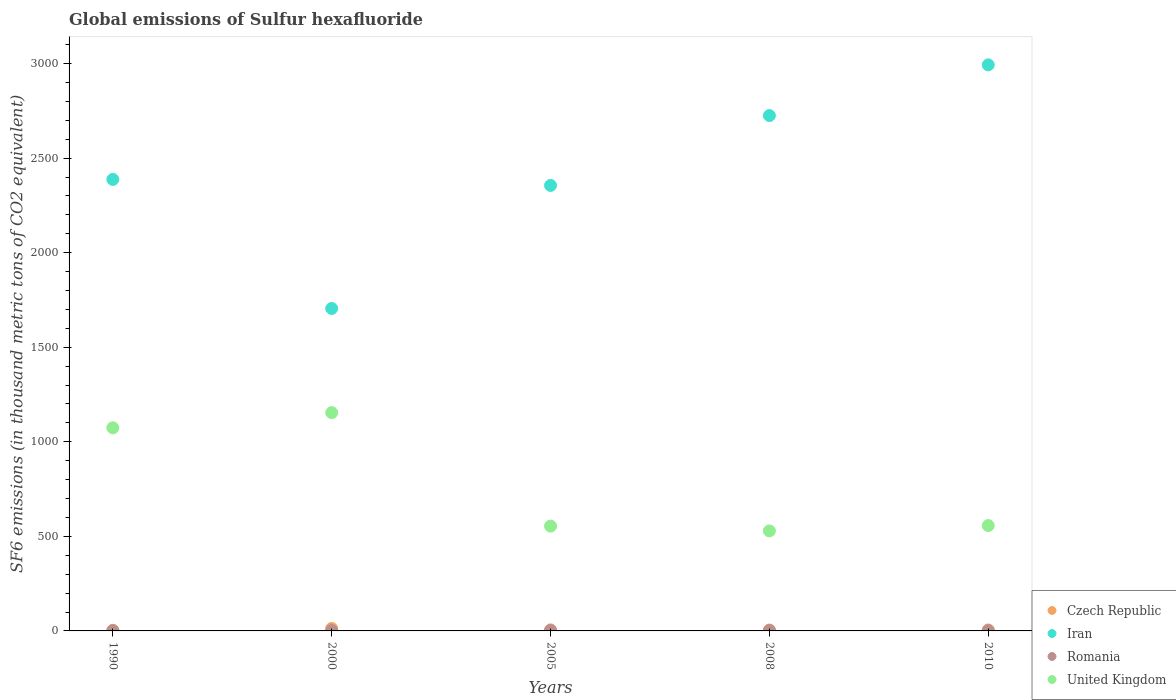What is the global emissions of Sulfur hexafluoride in United Kingdom in 2000?
Provide a short and direct response. 1154.1. Across all years, what is the maximum global emissions of Sulfur hexafluoride in United Kingdom?
Provide a short and direct response. 1154.1. Across all years, what is the minimum global emissions of Sulfur hexafluoride in Iran?
Ensure brevity in your answer.  1704.9. In which year was the global emissions of Sulfur hexafluoride in Romania maximum?
Your answer should be very brief. 2008. What is the total global emissions of Sulfur hexafluoride in Romania in the graph?
Make the answer very short. 10.1. What is the difference between the global emissions of Sulfur hexafluoride in United Kingdom in 1990 and that in 2008?
Your answer should be very brief. 545. What is the difference between the global emissions of Sulfur hexafluoride in Romania in 1990 and the global emissions of Sulfur hexafluoride in Czech Republic in 2008?
Provide a succinct answer. -3.1. What is the average global emissions of Sulfur hexafluoride in United Kingdom per year?
Provide a succinct answer. 773.62. In the year 2008, what is the difference between the global emissions of Sulfur hexafluoride in United Kingdom and global emissions of Sulfur hexafluoride in Iran?
Your answer should be very brief. -2196. What is the ratio of the global emissions of Sulfur hexafluoride in Iran in 2000 to that in 2008?
Offer a terse response. 0.63. Is the global emissions of Sulfur hexafluoride in Romania in 1990 less than that in 2010?
Your answer should be very brief. Yes. What is the difference between the highest and the second highest global emissions of Sulfur hexafluoride in Romania?
Your answer should be very brief. 0.1. What is the difference between the highest and the lowest global emissions of Sulfur hexafluoride in Romania?
Ensure brevity in your answer.  0.7. In how many years, is the global emissions of Sulfur hexafluoride in Romania greater than the average global emissions of Sulfur hexafluoride in Romania taken over all years?
Offer a terse response. 2. Is the sum of the global emissions of Sulfur hexafluoride in Czech Republic in 1990 and 2010 greater than the maximum global emissions of Sulfur hexafluoride in Iran across all years?
Make the answer very short. No. Is it the case that in every year, the sum of the global emissions of Sulfur hexafluoride in United Kingdom and global emissions of Sulfur hexafluoride in Czech Republic  is greater than the sum of global emissions of Sulfur hexafluoride in Romania and global emissions of Sulfur hexafluoride in Iran?
Make the answer very short. No. Does the global emissions of Sulfur hexafluoride in Czech Republic monotonically increase over the years?
Offer a very short reply. No. Where does the legend appear in the graph?
Provide a short and direct response. Bottom right. How are the legend labels stacked?
Your answer should be very brief. Vertical. What is the title of the graph?
Make the answer very short. Global emissions of Sulfur hexafluoride. What is the label or title of the X-axis?
Offer a very short reply. Years. What is the label or title of the Y-axis?
Keep it short and to the point. SF6 emissions (in thousand metric tons of CO2 equivalent). What is the SF6 emissions (in thousand metric tons of CO2 equivalent) in Iran in 1990?
Provide a succinct answer. 2387.3. What is the SF6 emissions (in thousand metric tons of CO2 equivalent) of Romania in 1990?
Provide a succinct answer. 1.6. What is the SF6 emissions (in thousand metric tons of CO2 equivalent) of United Kingdom in 1990?
Your answer should be very brief. 1073.9. What is the SF6 emissions (in thousand metric tons of CO2 equivalent) in Iran in 2000?
Give a very brief answer. 1704.9. What is the SF6 emissions (in thousand metric tons of CO2 equivalent) in United Kingdom in 2000?
Keep it short and to the point. 1154.1. What is the SF6 emissions (in thousand metric tons of CO2 equivalent) in Iran in 2005?
Your answer should be compact. 2355.5. What is the SF6 emissions (in thousand metric tons of CO2 equivalent) in United Kingdom in 2005?
Keep it short and to the point. 554.2. What is the SF6 emissions (in thousand metric tons of CO2 equivalent) of Iran in 2008?
Provide a succinct answer. 2724.9. What is the SF6 emissions (in thousand metric tons of CO2 equivalent) of United Kingdom in 2008?
Ensure brevity in your answer.  528.9. What is the SF6 emissions (in thousand metric tons of CO2 equivalent) of Iran in 2010?
Your response must be concise. 2993. What is the SF6 emissions (in thousand metric tons of CO2 equivalent) of United Kingdom in 2010?
Make the answer very short. 557. Across all years, what is the maximum SF6 emissions (in thousand metric tons of CO2 equivalent) of Czech Republic?
Make the answer very short. 13. Across all years, what is the maximum SF6 emissions (in thousand metric tons of CO2 equivalent) in Iran?
Give a very brief answer. 2993. Across all years, what is the maximum SF6 emissions (in thousand metric tons of CO2 equivalent) of United Kingdom?
Your answer should be compact. 1154.1. Across all years, what is the minimum SF6 emissions (in thousand metric tons of CO2 equivalent) of Iran?
Your answer should be very brief. 1704.9. Across all years, what is the minimum SF6 emissions (in thousand metric tons of CO2 equivalent) of United Kingdom?
Keep it short and to the point. 528.9. What is the total SF6 emissions (in thousand metric tons of CO2 equivalent) of Czech Republic in the graph?
Offer a very short reply. 31.6. What is the total SF6 emissions (in thousand metric tons of CO2 equivalent) of Iran in the graph?
Provide a succinct answer. 1.22e+04. What is the total SF6 emissions (in thousand metric tons of CO2 equivalent) of Romania in the graph?
Provide a succinct answer. 10.1. What is the total SF6 emissions (in thousand metric tons of CO2 equivalent) of United Kingdom in the graph?
Offer a very short reply. 3868.1. What is the difference between the SF6 emissions (in thousand metric tons of CO2 equivalent) of Iran in 1990 and that in 2000?
Give a very brief answer. 682.4. What is the difference between the SF6 emissions (in thousand metric tons of CO2 equivalent) of Romania in 1990 and that in 2000?
Offer a terse response. -0.4. What is the difference between the SF6 emissions (in thousand metric tons of CO2 equivalent) in United Kingdom in 1990 and that in 2000?
Keep it short and to the point. -80.2. What is the difference between the SF6 emissions (in thousand metric tons of CO2 equivalent) in Iran in 1990 and that in 2005?
Give a very brief answer. 31.8. What is the difference between the SF6 emissions (in thousand metric tons of CO2 equivalent) in Romania in 1990 and that in 2005?
Offer a terse response. -0.6. What is the difference between the SF6 emissions (in thousand metric tons of CO2 equivalent) in United Kingdom in 1990 and that in 2005?
Make the answer very short. 519.7. What is the difference between the SF6 emissions (in thousand metric tons of CO2 equivalent) in Iran in 1990 and that in 2008?
Keep it short and to the point. -337.6. What is the difference between the SF6 emissions (in thousand metric tons of CO2 equivalent) of United Kingdom in 1990 and that in 2008?
Your response must be concise. 545. What is the difference between the SF6 emissions (in thousand metric tons of CO2 equivalent) in Iran in 1990 and that in 2010?
Offer a very short reply. -605.7. What is the difference between the SF6 emissions (in thousand metric tons of CO2 equivalent) in Romania in 1990 and that in 2010?
Keep it short and to the point. -0.4. What is the difference between the SF6 emissions (in thousand metric tons of CO2 equivalent) in United Kingdom in 1990 and that in 2010?
Provide a succinct answer. 516.9. What is the difference between the SF6 emissions (in thousand metric tons of CO2 equivalent) in Czech Republic in 2000 and that in 2005?
Your response must be concise. 7.4. What is the difference between the SF6 emissions (in thousand metric tons of CO2 equivalent) of Iran in 2000 and that in 2005?
Your answer should be very brief. -650.6. What is the difference between the SF6 emissions (in thousand metric tons of CO2 equivalent) in United Kingdom in 2000 and that in 2005?
Ensure brevity in your answer.  599.9. What is the difference between the SF6 emissions (in thousand metric tons of CO2 equivalent) in Iran in 2000 and that in 2008?
Make the answer very short. -1020. What is the difference between the SF6 emissions (in thousand metric tons of CO2 equivalent) in United Kingdom in 2000 and that in 2008?
Provide a short and direct response. 625.2. What is the difference between the SF6 emissions (in thousand metric tons of CO2 equivalent) of Czech Republic in 2000 and that in 2010?
Your answer should be very brief. 8. What is the difference between the SF6 emissions (in thousand metric tons of CO2 equivalent) of Iran in 2000 and that in 2010?
Provide a succinct answer. -1288.1. What is the difference between the SF6 emissions (in thousand metric tons of CO2 equivalent) of Romania in 2000 and that in 2010?
Your response must be concise. 0. What is the difference between the SF6 emissions (in thousand metric tons of CO2 equivalent) in United Kingdom in 2000 and that in 2010?
Your answer should be very brief. 597.1. What is the difference between the SF6 emissions (in thousand metric tons of CO2 equivalent) in Iran in 2005 and that in 2008?
Ensure brevity in your answer.  -369.4. What is the difference between the SF6 emissions (in thousand metric tons of CO2 equivalent) of Romania in 2005 and that in 2008?
Your answer should be compact. -0.1. What is the difference between the SF6 emissions (in thousand metric tons of CO2 equivalent) in United Kingdom in 2005 and that in 2008?
Give a very brief answer. 25.3. What is the difference between the SF6 emissions (in thousand metric tons of CO2 equivalent) of Iran in 2005 and that in 2010?
Provide a short and direct response. -637.5. What is the difference between the SF6 emissions (in thousand metric tons of CO2 equivalent) in United Kingdom in 2005 and that in 2010?
Your response must be concise. -2.8. What is the difference between the SF6 emissions (in thousand metric tons of CO2 equivalent) of Czech Republic in 2008 and that in 2010?
Your answer should be compact. -0.3. What is the difference between the SF6 emissions (in thousand metric tons of CO2 equivalent) in Iran in 2008 and that in 2010?
Your answer should be compact. -268.1. What is the difference between the SF6 emissions (in thousand metric tons of CO2 equivalent) in United Kingdom in 2008 and that in 2010?
Give a very brief answer. -28.1. What is the difference between the SF6 emissions (in thousand metric tons of CO2 equivalent) of Czech Republic in 1990 and the SF6 emissions (in thousand metric tons of CO2 equivalent) of Iran in 2000?
Ensure brevity in your answer.  -1701.6. What is the difference between the SF6 emissions (in thousand metric tons of CO2 equivalent) in Czech Republic in 1990 and the SF6 emissions (in thousand metric tons of CO2 equivalent) in Romania in 2000?
Ensure brevity in your answer.  1.3. What is the difference between the SF6 emissions (in thousand metric tons of CO2 equivalent) in Czech Republic in 1990 and the SF6 emissions (in thousand metric tons of CO2 equivalent) in United Kingdom in 2000?
Make the answer very short. -1150.8. What is the difference between the SF6 emissions (in thousand metric tons of CO2 equivalent) of Iran in 1990 and the SF6 emissions (in thousand metric tons of CO2 equivalent) of Romania in 2000?
Offer a very short reply. 2385.3. What is the difference between the SF6 emissions (in thousand metric tons of CO2 equivalent) in Iran in 1990 and the SF6 emissions (in thousand metric tons of CO2 equivalent) in United Kingdom in 2000?
Your answer should be compact. 1233.2. What is the difference between the SF6 emissions (in thousand metric tons of CO2 equivalent) in Romania in 1990 and the SF6 emissions (in thousand metric tons of CO2 equivalent) in United Kingdom in 2000?
Offer a very short reply. -1152.5. What is the difference between the SF6 emissions (in thousand metric tons of CO2 equivalent) in Czech Republic in 1990 and the SF6 emissions (in thousand metric tons of CO2 equivalent) in Iran in 2005?
Keep it short and to the point. -2352.2. What is the difference between the SF6 emissions (in thousand metric tons of CO2 equivalent) of Czech Republic in 1990 and the SF6 emissions (in thousand metric tons of CO2 equivalent) of United Kingdom in 2005?
Provide a short and direct response. -550.9. What is the difference between the SF6 emissions (in thousand metric tons of CO2 equivalent) in Iran in 1990 and the SF6 emissions (in thousand metric tons of CO2 equivalent) in Romania in 2005?
Your answer should be compact. 2385.1. What is the difference between the SF6 emissions (in thousand metric tons of CO2 equivalent) of Iran in 1990 and the SF6 emissions (in thousand metric tons of CO2 equivalent) of United Kingdom in 2005?
Provide a short and direct response. 1833.1. What is the difference between the SF6 emissions (in thousand metric tons of CO2 equivalent) in Romania in 1990 and the SF6 emissions (in thousand metric tons of CO2 equivalent) in United Kingdom in 2005?
Your response must be concise. -552.6. What is the difference between the SF6 emissions (in thousand metric tons of CO2 equivalent) in Czech Republic in 1990 and the SF6 emissions (in thousand metric tons of CO2 equivalent) in Iran in 2008?
Ensure brevity in your answer.  -2721.6. What is the difference between the SF6 emissions (in thousand metric tons of CO2 equivalent) in Czech Republic in 1990 and the SF6 emissions (in thousand metric tons of CO2 equivalent) in United Kingdom in 2008?
Offer a very short reply. -525.6. What is the difference between the SF6 emissions (in thousand metric tons of CO2 equivalent) in Iran in 1990 and the SF6 emissions (in thousand metric tons of CO2 equivalent) in Romania in 2008?
Make the answer very short. 2385. What is the difference between the SF6 emissions (in thousand metric tons of CO2 equivalent) in Iran in 1990 and the SF6 emissions (in thousand metric tons of CO2 equivalent) in United Kingdom in 2008?
Your response must be concise. 1858.4. What is the difference between the SF6 emissions (in thousand metric tons of CO2 equivalent) of Romania in 1990 and the SF6 emissions (in thousand metric tons of CO2 equivalent) of United Kingdom in 2008?
Ensure brevity in your answer.  -527.3. What is the difference between the SF6 emissions (in thousand metric tons of CO2 equivalent) of Czech Republic in 1990 and the SF6 emissions (in thousand metric tons of CO2 equivalent) of Iran in 2010?
Provide a short and direct response. -2989.7. What is the difference between the SF6 emissions (in thousand metric tons of CO2 equivalent) of Czech Republic in 1990 and the SF6 emissions (in thousand metric tons of CO2 equivalent) of United Kingdom in 2010?
Your response must be concise. -553.7. What is the difference between the SF6 emissions (in thousand metric tons of CO2 equivalent) in Iran in 1990 and the SF6 emissions (in thousand metric tons of CO2 equivalent) in Romania in 2010?
Provide a short and direct response. 2385.3. What is the difference between the SF6 emissions (in thousand metric tons of CO2 equivalent) in Iran in 1990 and the SF6 emissions (in thousand metric tons of CO2 equivalent) in United Kingdom in 2010?
Your answer should be very brief. 1830.3. What is the difference between the SF6 emissions (in thousand metric tons of CO2 equivalent) of Romania in 1990 and the SF6 emissions (in thousand metric tons of CO2 equivalent) of United Kingdom in 2010?
Keep it short and to the point. -555.4. What is the difference between the SF6 emissions (in thousand metric tons of CO2 equivalent) in Czech Republic in 2000 and the SF6 emissions (in thousand metric tons of CO2 equivalent) in Iran in 2005?
Give a very brief answer. -2342.5. What is the difference between the SF6 emissions (in thousand metric tons of CO2 equivalent) in Czech Republic in 2000 and the SF6 emissions (in thousand metric tons of CO2 equivalent) in United Kingdom in 2005?
Provide a succinct answer. -541.2. What is the difference between the SF6 emissions (in thousand metric tons of CO2 equivalent) of Iran in 2000 and the SF6 emissions (in thousand metric tons of CO2 equivalent) of Romania in 2005?
Ensure brevity in your answer.  1702.7. What is the difference between the SF6 emissions (in thousand metric tons of CO2 equivalent) of Iran in 2000 and the SF6 emissions (in thousand metric tons of CO2 equivalent) of United Kingdom in 2005?
Provide a succinct answer. 1150.7. What is the difference between the SF6 emissions (in thousand metric tons of CO2 equivalent) in Romania in 2000 and the SF6 emissions (in thousand metric tons of CO2 equivalent) in United Kingdom in 2005?
Make the answer very short. -552.2. What is the difference between the SF6 emissions (in thousand metric tons of CO2 equivalent) in Czech Republic in 2000 and the SF6 emissions (in thousand metric tons of CO2 equivalent) in Iran in 2008?
Provide a short and direct response. -2711.9. What is the difference between the SF6 emissions (in thousand metric tons of CO2 equivalent) of Czech Republic in 2000 and the SF6 emissions (in thousand metric tons of CO2 equivalent) of United Kingdom in 2008?
Ensure brevity in your answer.  -515.9. What is the difference between the SF6 emissions (in thousand metric tons of CO2 equivalent) in Iran in 2000 and the SF6 emissions (in thousand metric tons of CO2 equivalent) in Romania in 2008?
Ensure brevity in your answer.  1702.6. What is the difference between the SF6 emissions (in thousand metric tons of CO2 equivalent) of Iran in 2000 and the SF6 emissions (in thousand metric tons of CO2 equivalent) of United Kingdom in 2008?
Give a very brief answer. 1176. What is the difference between the SF6 emissions (in thousand metric tons of CO2 equivalent) of Romania in 2000 and the SF6 emissions (in thousand metric tons of CO2 equivalent) of United Kingdom in 2008?
Provide a succinct answer. -526.9. What is the difference between the SF6 emissions (in thousand metric tons of CO2 equivalent) of Czech Republic in 2000 and the SF6 emissions (in thousand metric tons of CO2 equivalent) of Iran in 2010?
Offer a terse response. -2980. What is the difference between the SF6 emissions (in thousand metric tons of CO2 equivalent) in Czech Republic in 2000 and the SF6 emissions (in thousand metric tons of CO2 equivalent) in United Kingdom in 2010?
Your answer should be compact. -544. What is the difference between the SF6 emissions (in thousand metric tons of CO2 equivalent) of Iran in 2000 and the SF6 emissions (in thousand metric tons of CO2 equivalent) of Romania in 2010?
Give a very brief answer. 1702.9. What is the difference between the SF6 emissions (in thousand metric tons of CO2 equivalent) of Iran in 2000 and the SF6 emissions (in thousand metric tons of CO2 equivalent) of United Kingdom in 2010?
Offer a very short reply. 1147.9. What is the difference between the SF6 emissions (in thousand metric tons of CO2 equivalent) of Romania in 2000 and the SF6 emissions (in thousand metric tons of CO2 equivalent) of United Kingdom in 2010?
Offer a terse response. -555. What is the difference between the SF6 emissions (in thousand metric tons of CO2 equivalent) of Czech Republic in 2005 and the SF6 emissions (in thousand metric tons of CO2 equivalent) of Iran in 2008?
Your answer should be very brief. -2719.3. What is the difference between the SF6 emissions (in thousand metric tons of CO2 equivalent) of Czech Republic in 2005 and the SF6 emissions (in thousand metric tons of CO2 equivalent) of Romania in 2008?
Keep it short and to the point. 3.3. What is the difference between the SF6 emissions (in thousand metric tons of CO2 equivalent) in Czech Republic in 2005 and the SF6 emissions (in thousand metric tons of CO2 equivalent) in United Kingdom in 2008?
Give a very brief answer. -523.3. What is the difference between the SF6 emissions (in thousand metric tons of CO2 equivalent) in Iran in 2005 and the SF6 emissions (in thousand metric tons of CO2 equivalent) in Romania in 2008?
Ensure brevity in your answer.  2353.2. What is the difference between the SF6 emissions (in thousand metric tons of CO2 equivalent) in Iran in 2005 and the SF6 emissions (in thousand metric tons of CO2 equivalent) in United Kingdom in 2008?
Your answer should be very brief. 1826.6. What is the difference between the SF6 emissions (in thousand metric tons of CO2 equivalent) of Romania in 2005 and the SF6 emissions (in thousand metric tons of CO2 equivalent) of United Kingdom in 2008?
Ensure brevity in your answer.  -526.7. What is the difference between the SF6 emissions (in thousand metric tons of CO2 equivalent) in Czech Republic in 2005 and the SF6 emissions (in thousand metric tons of CO2 equivalent) in Iran in 2010?
Offer a very short reply. -2987.4. What is the difference between the SF6 emissions (in thousand metric tons of CO2 equivalent) of Czech Republic in 2005 and the SF6 emissions (in thousand metric tons of CO2 equivalent) of Romania in 2010?
Your response must be concise. 3.6. What is the difference between the SF6 emissions (in thousand metric tons of CO2 equivalent) of Czech Republic in 2005 and the SF6 emissions (in thousand metric tons of CO2 equivalent) of United Kingdom in 2010?
Keep it short and to the point. -551.4. What is the difference between the SF6 emissions (in thousand metric tons of CO2 equivalent) of Iran in 2005 and the SF6 emissions (in thousand metric tons of CO2 equivalent) of Romania in 2010?
Your response must be concise. 2353.5. What is the difference between the SF6 emissions (in thousand metric tons of CO2 equivalent) of Iran in 2005 and the SF6 emissions (in thousand metric tons of CO2 equivalent) of United Kingdom in 2010?
Provide a succinct answer. 1798.5. What is the difference between the SF6 emissions (in thousand metric tons of CO2 equivalent) in Romania in 2005 and the SF6 emissions (in thousand metric tons of CO2 equivalent) in United Kingdom in 2010?
Offer a terse response. -554.8. What is the difference between the SF6 emissions (in thousand metric tons of CO2 equivalent) in Czech Republic in 2008 and the SF6 emissions (in thousand metric tons of CO2 equivalent) in Iran in 2010?
Offer a very short reply. -2988.3. What is the difference between the SF6 emissions (in thousand metric tons of CO2 equivalent) in Czech Republic in 2008 and the SF6 emissions (in thousand metric tons of CO2 equivalent) in Romania in 2010?
Keep it short and to the point. 2.7. What is the difference between the SF6 emissions (in thousand metric tons of CO2 equivalent) in Czech Republic in 2008 and the SF6 emissions (in thousand metric tons of CO2 equivalent) in United Kingdom in 2010?
Provide a short and direct response. -552.3. What is the difference between the SF6 emissions (in thousand metric tons of CO2 equivalent) in Iran in 2008 and the SF6 emissions (in thousand metric tons of CO2 equivalent) in Romania in 2010?
Provide a succinct answer. 2722.9. What is the difference between the SF6 emissions (in thousand metric tons of CO2 equivalent) of Iran in 2008 and the SF6 emissions (in thousand metric tons of CO2 equivalent) of United Kingdom in 2010?
Give a very brief answer. 2167.9. What is the difference between the SF6 emissions (in thousand metric tons of CO2 equivalent) of Romania in 2008 and the SF6 emissions (in thousand metric tons of CO2 equivalent) of United Kingdom in 2010?
Your response must be concise. -554.7. What is the average SF6 emissions (in thousand metric tons of CO2 equivalent) of Czech Republic per year?
Offer a very short reply. 6.32. What is the average SF6 emissions (in thousand metric tons of CO2 equivalent) of Iran per year?
Give a very brief answer. 2433.12. What is the average SF6 emissions (in thousand metric tons of CO2 equivalent) of Romania per year?
Ensure brevity in your answer.  2.02. What is the average SF6 emissions (in thousand metric tons of CO2 equivalent) in United Kingdom per year?
Your answer should be very brief. 773.62. In the year 1990, what is the difference between the SF6 emissions (in thousand metric tons of CO2 equivalent) of Czech Republic and SF6 emissions (in thousand metric tons of CO2 equivalent) of Iran?
Provide a succinct answer. -2384. In the year 1990, what is the difference between the SF6 emissions (in thousand metric tons of CO2 equivalent) of Czech Republic and SF6 emissions (in thousand metric tons of CO2 equivalent) of Romania?
Offer a very short reply. 1.7. In the year 1990, what is the difference between the SF6 emissions (in thousand metric tons of CO2 equivalent) of Czech Republic and SF6 emissions (in thousand metric tons of CO2 equivalent) of United Kingdom?
Ensure brevity in your answer.  -1070.6. In the year 1990, what is the difference between the SF6 emissions (in thousand metric tons of CO2 equivalent) of Iran and SF6 emissions (in thousand metric tons of CO2 equivalent) of Romania?
Provide a short and direct response. 2385.7. In the year 1990, what is the difference between the SF6 emissions (in thousand metric tons of CO2 equivalent) of Iran and SF6 emissions (in thousand metric tons of CO2 equivalent) of United Kingdom?
Offer a very short reply. 1313.4. In the year 1990, what is the difference between the SF6 emissions (in thousand metric tons of CO2 equivalent) in Romania and SF6 emissions (in thousand metric tons of CO2 equivalent) in United Kingdom?
Provide a short and direct response. -1072.3. In the year 2000, what is the difference between the SF6 emissions (in thousand metric tons of CO2 equivalent) of Czech Republic and SF6 emissions (in thousand metric tons of CO2 equivalent) of Iran?
Ensure brevity in your answer.  -1691.9. In the year 2000, what is the difference between the SF6 emissions (in thousand metric tons of CO2 equivalent) in Czech Republic and SF6 emissions (in thousand metric tons of CO2 equivalent) in United Kingdom?
Offer a terse response. -1141.1. In the year 2000, what is the difference between the SF6 emissions (in thousand metric tons of CO2 equivalent) of Iran and SF6 emissions (in thousand metric tons of CO2 equivalent) of Romania?
Offer a terse response. 1702.9. In the year 2000, what is the difference between the SF6 emissions (in thousand metric tons of CO2 equivalent) in Iran and SF6 emissions (in thousand metric tons of CO2 equivalent) in United Kingdom?
Your answer should be very brief. 550.8. In the year 2000, what is the difference between the SF6 emissions (in thousand metric tons of CO2 equivalent) of Romania and SF6 emissions (in thousand metric tons of CO2 equivalent) of United Kingdom?
Give a very brief answer. -1152.1. In the year 2005, what is the difference between the SF6 emissions (in thousand metric tons of CO2 equivalent) of Czech Republic and SF6 emissions (in thousand metric tons of CO2 equivalent) of Iran?
Offer a terse response. -2349.9. In the year 2005, what is the difference between the SF6 emissions (in thousand metric tons of CO2 equivalent) of Czech Republic and SF6 emissions (in thousand metric tons of CO2 equivalent) of United Kingdom?
Provide a succinct answer. -548.6. In the year 2005, what is the difference between the SF6 emissions (in thousand metric tons of CO2 equivalent) of Iran and SF6 emissions (in thousand metric tons of CO2 equivalent) of Romania?
Your answer should be very brief. 2353.3. In the year 2005, what is the difference between the SF6 emissions (in thousand metric tons of CO2 equivalent) in Iran and SF6 emissions (in thousand metric tons of CO2 equivalent) in United Kingdom?
Provide a short and direct response. 1801.3. In the year 2005, what is the difference between the SF6 emissions (in thousand metric tons of CO2 equivalent) in Romania and SF6 emissions (in thousand metric tons of CO2 equivalent) in United Kingdom?
Provide a succinct answer. -552. In the year 2008, what is the difference between the SF6 emissions (in thousand metric tons of CO2 equivalent) of Czech Republic and SF6 emissions (in thousand metric tons of CO2 equivalent) of Iran?
Offer a terse response. -2720.2. In the year 2008, what is the difference between the SF6 emissions (in thousand metric tons of CO2 equivalent) in Czech Republic and SF6 emissions (in thousand metric tons of CO2 equivalent) in Romania?
Your answer should be very brief. 2.4. In the year 2008, what is the difference between the SF6 emissions (in thousand metric tons of CO2 equivalent) in Czech Republic and SF6 emissions (in thousand metric tons of CO2 equivalent) in United Kingdom?
Offer a terse response. -524.2. In the year 2008, what is the difference between the SF6 emissions (in thousand metric tons of CO2 equivalent) in Iran and SF6 emissions (in thousand metric tons of CO2 equivalent) in Romania?
Provide a short and direct response. 2722.6. In the year 2008, what is the difference between the SF6 emissions (in thousand metric tons of CO2 equivalent) of Iran and SF6 emissions (in thousand metric tons of CO2 equivalent) of United Kingdom?
Make the answer very short. 2196. In the year 2008, what is the difference between the SF6 emissions (in thousand metric tons of CO2 equivalent) of Romania and SF6 emissions (in thousand metric tons of CO2 equivalent) of United Kingdom?
Give a very brief answer. -526.6. In the year 2010, what is the difference between the SF6 emissions (in thousand metric tons of CO2 equivalent) in Czech Republic and SF6 emissions (in thousand metric tons of CO2 equivalent) in Iran?
Your response must be concise. -2988. In the year 2010, what is the difference between the SF6 emissions (in thousand metric tons of CO2 equivalent) in Czech Republic and SF6 emissions (in thousand metric tons of CO2 equivalent) in Romania?
Your answer should be very brief. 3. In the year 2010, what is the difference between the SF6 emissions (in thousand metric tons of CO2 equivalent) of Czech Republic and SF6 emissions (in thousand metric tons of CO2 equivalent) of United Kingdom?
Make the answer very short. -552. In the year 2010, what is the difference between the SF6 emissions (in thousand metric tons of CO2 equivalent) of Iran and SF6 emissions (in thousand metric tons of CO2 equivalent) of Romania?
Offer a very short reply. 2991. In the year 2010, what is the difference between the SF6 emissions (in thousand metric tons of CO2 equivalent) in Iran and SF6 emissions (in thousand metric tons of CO2 equivalent) in United Kingdom?
Your answer should be compact. 2436. In the year 2010, what is the difference between the SF6 emissions (in thousand metric tons of CO2 equivalent) in Romania and SF6 emissions (in thousand metric tons of CO2 equivalent) in United Kingdom?
Ensure brevity in your answer.  -555. What is the ratio of the SF6 emissions (in thousand metric tons of CO2 equivalent) in Czech Republic in 1990 to that in 2000?
Your answer should be very brief. 0.25. What is the ratio of the SF6 emissions (in thousand metric tons of CO2 equivalent) of Iran in 1990 to that in 2000?
Give a very brief answer. 1.4. What is the ratio of the SF6 emissions (in thousand metric tons of CO2 equivalent) of Romania in 1990 to that in 2000?
Your answer should be very brief. 0.8. What is the ratio of the SF6 emissions (in thousand metric tons of CO2 equivalent) of United Kingdom in 1990 to that in 2000?
Provide a short and direct response. 0.93. What is the ratio of the SF6 emissions (in thousand metric tons of CO2 equivalent) in Czech Republic in 1990 to that in 2005?
Your response must be concise. 0.59. What is the ratio of the SF6 emissions (in thousand metric tons of CO2 equivalent) in Iran in 1990 to that in 2005?
Offer a terse response. 1.01. What is the ratio of the SF6 emissions (in thousand metric tons of CO2 equivalent) of Romania in 1990 to that in 2005?
Give a very brief answer. 0.73. What is the ratio of the SF6 emissions (in thousand metric tons of CO2 equivalent) of United Kingdom in 1990 to that in 2005?
Offer a very short reply. 1.94. What is the ratio of the SF6 emissions (in thousand metric tons of CO2 equivalent) of Czech Republic in 1990 to that in 2008?
Provide a short and direct response. 0.7. What is the ratio of the SF6 emissions (in thousand metric tons of CO2 equivalent) in Iran in 1990 to that in 2008?
Your answer should be very brief. 0.88. What is the ratio of the SF6 emissions (in thousand metric tons of CO2 equivalent) of Romania in 1990 to that in 2008?
Your answer should be very brief. 0.7. What is the ratio of the SF6 emissions (in thousand metric tons of CO2 equivalent) of United Kingdom in 1990 to that in 2008?
Offer a very short reply. 2.03. What is the ratio of the SF6 emissions (in thousand metric tons of CO2 equivalent) in Czech Republic in 1990 to that in 2010?
Give a very brief answer. 0.66. What is the ratio of the SF6 emissions (in thousand metric tons of CO2 equivalent) of Iran in 1990 to that in 2010?
Make the answer very short. 0.8. What is the ratio of the SF6 emissions (in thousand metric tons of CO2 equivalent) of Romania in 1990 to that in 2010?
Your answer should be compact. 0.8. What is the ratio of the SF6 emissions (in thousand metric tons of CO2 equivalent) in United Kingdom in 1990 to that in 2010?
Make the answer very short. 1.93. What is the ratio of the SF6 emissions (in thousand metric tons of CO2 equivalent) of Czech Republic in 2000 to that in 2005?
Keep it short and to the point. 2.32. What is the ratio of the SF6 emissions (in thousand metric tons of CO2 equivalent) of Iran in 2000 to that in 2005?
Offer a very short reply. 0.72. What is the ratio of the SF6 emissions (in thousand metric tons of CO2 equivalent) in United Kingdom in 2000 to that in 2005?
Provide a short and direct response. 2.08. What is the ratio of the SF6 emissions (in thousand metric tons of CO2 equivalent) in Czech Republic in 2000 to that in 2008?
Your answer should be very brief. 2.77. What is the ratio of the SF6 emissions (in thousand metric tons of CO2 equivalent) of Iran in 2000 to that in 2008?
Ensure brevity in your answer.  0.63. What is the ratio of the SF6 emissions (in thousand metric tons of CO2 equivalent) of Romania in 2000 to that in 2008?
Ensure brevity in your answer.  0.87. What is the ratio of the SF6 emissions (in thousand metric tons of CO2 equivalent) in United Kingdom in 2000 to that in 2008?
Give a very brief answer. 2.18. What is the ratio of the SF6 emissions (in thousand metric tons of CO2 equivalent) of Czech Republic in 2000 to that in 2010?
Offer a very short reply. 2.6. What is the ratio of the SF6 emissions (in thousand metric tons of CO2 equivalent) of Iran in 2000 to that in 2010?
Provide a succinct answer. 0.57. What is the ratio of the SF6 emissions (in thousand metric tons of CO2 equivalent) in United Kingdom in 2000 to that in 2010?
Your answer should be very brief. 2.07. What is the ratio of the SF6 emissions (in thousand metric tons of CO2 equivalent) in Czech Republic in 2005 to that in 2008?
Make the answer very short. 1.19. What is the ratio of the SF6 emissions (in thousand metric tons of CO2 equivalent) of Iran in 2005 to that in 2008?
Your answer should be compact. 0.86. What is the ratio of the SF6 emissions (in thousand metric tons of CO2 equivalent) of Romania in 2005 to that in 2008?
Your response must be concise. 0.96. What is the ratio of the SF6 emissions (in thousand metric tons of CO2 equivalent) of United Kingdom in 2005 to that in 2008?
Your response must be concise. 1.05. What is the ratio of the SF6 emissions (in thousand metric tons of CO2 equivalent) in Czech Republic in 2005 to that in 2010?
Ensure brevity in your answer.  1.12. What is the ratio of the SF6 emissions (in thousand metric tons of CO2 equivalent) of Iran in 2005 to that in 2010?
Offer a very short reply. 0.79. What is the ratio of the SF6 emissions (in thousand metric tons of CO2 equivalent) of United Kingdom in 2005 to that in 2010?
Keep it short and to the point. 0.99. What is the ratio of the SF6 emissions (in thousand metric tons of CO2 equivalent) in Czech Republic in 2008 to that in 2010?
Your answer should be compact. 0.94. What is the ratio of the SF6 emissions (in thousand metric tons of CO2 equivalent) of Iran in 2008 to that in 2010?
Offer a very short reply. 0.91. What is the ratio of the SF6 emissions (in thousand metric tons of CO2 equivalent) of Romania in 2008 to that in 2010?
Offer a very short reply. 1.15. What is the ratio of the SF6 emissions (in thousand metric tons of CO2 equivalent) in United Kingdom in 2008 to that in 2010?
Provide a short and direct response. 0.95. What is the difference between the highest and the second highest SF6 emissions (in thousand metric tons of CO2 equivalent) in Czech Republic?
Ensure brevity in your answer.  7.4. What is the difference between the highest and the second highest SF6 emissions (in thousand metric tons of CO2 equivalent) in Iran?
Keep it short and to the point. 268.1. What is the difference between the highest and the second highest SF6 emissions (in thousand metric tons of CO2 equivalent) in Romania?
Your answer should be very brief. 0.1. What is the difference between the highest and the second highest SF6 emissions (in thousand metric tons of CO2 equivalent) in United Kingdom?
Provide a short and direct response. 80.2. What is the difference between the highest and the lowest SF6 emissions (in thousand metric tons of CO2 equivalent) in Czech Republic?
Your response must be concise. 9.7. What is the difference between the highest and the lowest SF6 emissions (in thousand metric tons of CO2 equivalent) in Iran?
Offer a very short reply. 1288.1. What is the difference between the highest and the lowest SF6 emissions (in thousand metric tons of CO2 equivalent) of Romania?
Your answer should be compact. 0.7. What is the difference between the highest and the lowest SF6 emissions (in thousand metric tons of CO2 equivalent) of United Kingdom?
Offer a terse response. 625.2. 